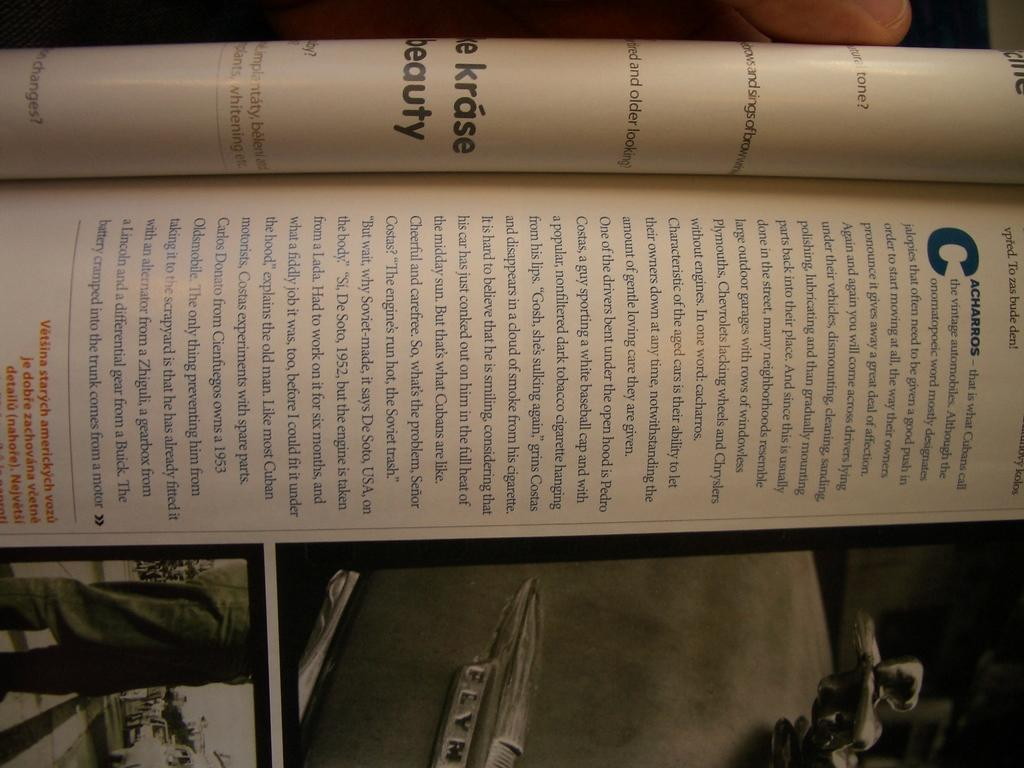<image>
Present a compact description of the photo's key features. The page is turned to information about Cacharros 